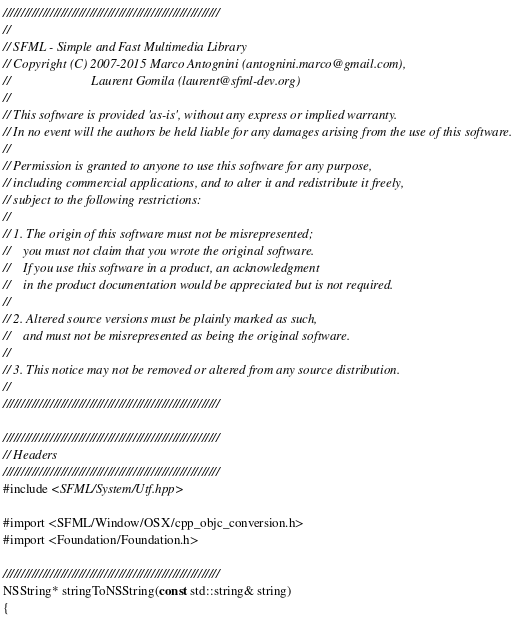Convert code to text. <code><loc_0><loc_0><loc_500><loc_500><_ObjectiveC_>////////////////////////////////////////////////////////////
//
// SFML - Simple and Fast Multimedia Library
// Copyright (C) 2007-2015 Marco Antognini (antognini.marco@gmail.com),
//                         Laurent Gomila (laurent@sfml-dev.org)
//
// This software is provided 'as-is', without any express or implied warranty.
// In no event will the authors be held liable for any damages arising from the use of this software.
//
// Permission is granted to anyone to use this software for any purpose,
// including commercial applications, and to alter it and redistribute it freely,
// subject to the following restrictions:
//
// 1. The origin of this software must not be misrepresented;
//    you must not claim that you wrote the original software.
//    If you use this software in a product, an acknowledgment
//    in the product documentation would be appreciated but is not required.
//
// 2. Altered source versions must be plainly marked as such,
//    and must not be misrepresented as being the original software.
//
// 3. This notice may not be removed or altered from any source distribution.
//
////////////////////////////////////////////////////////////

////////////////////////////////////////////////////////////
// Headers
////////////////////////////////////////////////////////////
#include <SFML/System/Utf.hpp>

#import <SFML/Window/OSX/cpp_objc_conversion.h>
#import <Foundation/Foundation.h>

////////////////////////////////////////////////////////////
NSString* stringToNSString(const std::string& string)
{</code> 